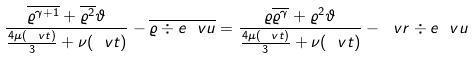Convert formula to latex. <formula><loc_0><loc_0><loc_500><loc_500>\frac { \overline { \varrho ^ { \gamma + 1 } } + \overline { \varrho ^ { 2 } } \vartheta } { \frac { 4 \mu ( \ v t ) } { 3 } + \nu ( \ v t ) } - \overline { \varrho \div e \ v u } = \frac { \varrho \overline { \varrho ^ { \gamma } } + \varrho ^ { 2 } \vartheta } { \frac { 4 \mu ( \ v t ) } { 3 } + \nu ( \ v t ) } - \ v r \div e \ v u</formula> 